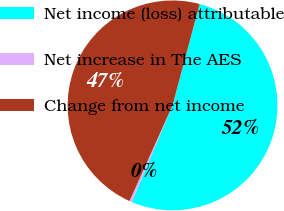Convert chart. <chart><loc_0><loc_0><loc_500><loc_500><pie_chart><fcel>Net income (loss) attributable<fcel>Net increase in The AES<fcel>Change from net income<nl><fcel>52.2%<fcel>0.37%<fcel>47.43%<nl></chart> 